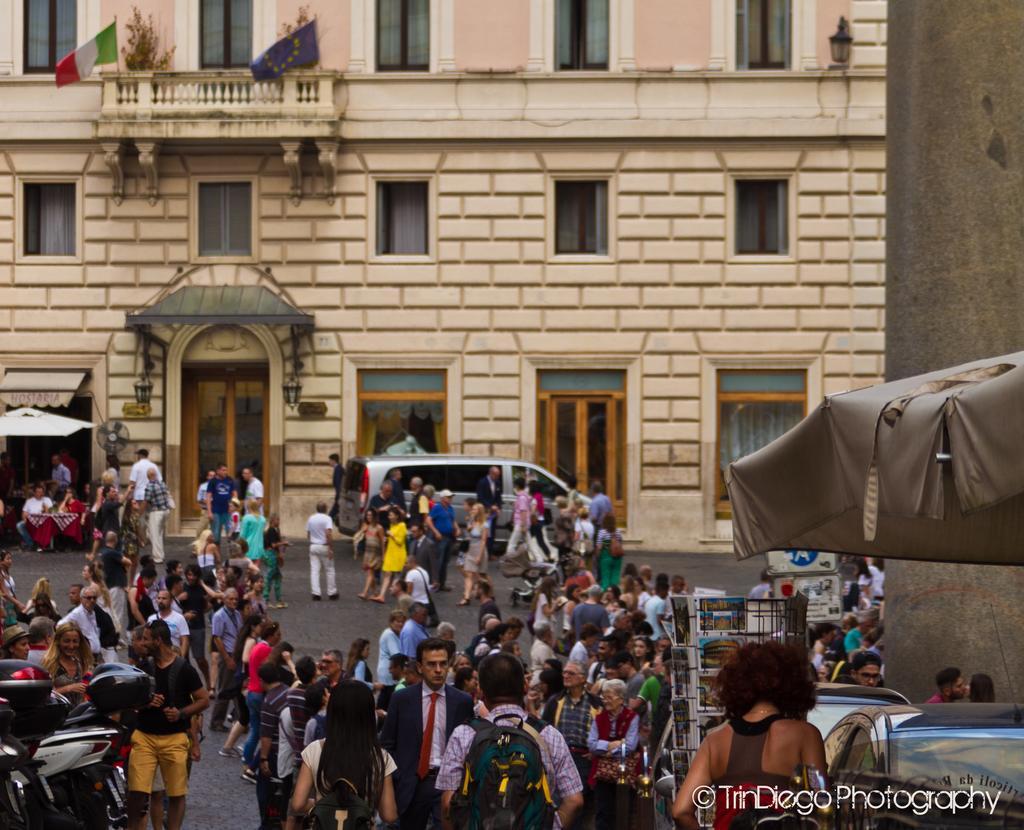Describe this image in one or two sentences. The picture is taken outside a city on the streets. In the foreground of the picture there are vehicles and people walking down the street. In the background there is a building, to building there are windows and a door. On the right there is a tent. On the left there is a tent. 